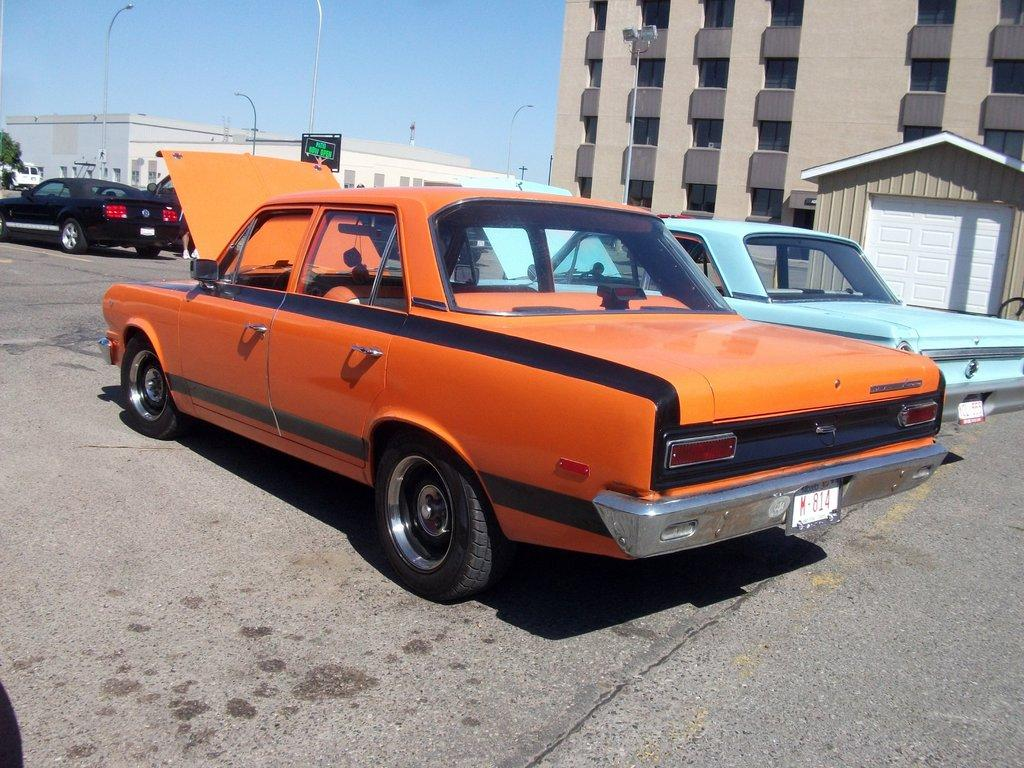What can be seen on the road in the image? There are cars parked on the road in the image. What can be seen in the distance behind the parked cars? There are buildings visible in the background of the image. How would you describe the sky in the image? The sky is clear in the image. How much weight can the salt carry in the image? There is no salt present in the image, so it is not possible to determine its weight or any potential carrying capacity. 